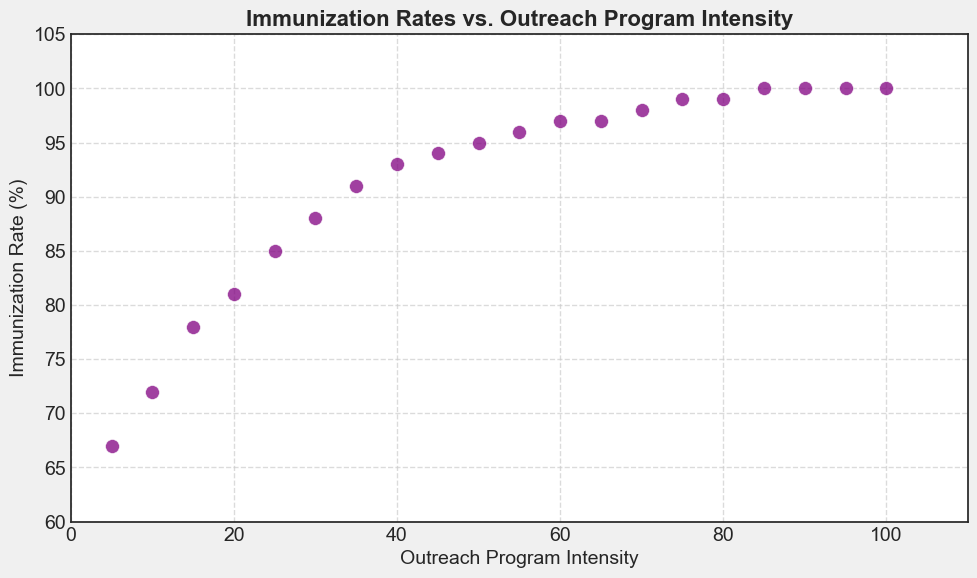What trend do you observe between Outreach Program Intensity and Immunization Rate? As Outreach Program Intensity increases, Immunization Rate also increases. The relationship appears to be positively correlated, indicating that more intense outreach programs are associated with higher immunization rates.
Answer: Positive correlation What is the Immunization Rate when the Outreach Program Intensity is 40? Locate the point where Outreach Program Intensity is 40 on the x-axis, and then look up to see where it intersects with the y-axis. The Immunization Rate at this point is 93%.
Answer: 93% At what value of Outreach Program Intensity does the Immunization Rate first reach 100%? Find the first data point where the y-axis value (Immunization Rate) reaches 100%. This occurs when Outreach Program Intensity is at 85.
Answer: 85 What is the difference in Immunization Rate between an Outreach Program Intensity of 25 and 50? Locate the Immunization Rates for Outreach Program Intensities of 25 and 50, which are 85% and 95% respectively. Subtract 85 from 95 to get the difference (95 - 85 = 10).
Answer: 10 Is there a point where increasing the Outreach Program Intensity does not increase the Immunization Rate? From Outreach Program Intensity of 85 onwards, the Immunization Rate is 100%, indicating that any further increase in intensity does not augment the Immunization Rate.
Answer: Yes At an Outreach Program Intensity of 30, how much higher is the Immunization Rate compared to an Intensity of 10? Locate the Immunization Rates for Outreach Program Intensities of 30 and 10, which are 88% and 72% respectively. Subtract 72 from 88 to find the difference (88 - 72 = 16).
Answer: 16 What is the average Immunization Rate for an Outreach Program Intensity ranging from 50 to 70? Find the Immunization Rates at 50, 55, 60, 65, and 70: 95%, 96%, 97%, 97%, and 98% respectively. Sum them up (95 + 96 + 97 + 97 + 98 = 483) and divide by 5 (483 / 5 = 96.6).
Answer: 96.6 Does the scatter plot show any outliers? Examine the scatter plot to see if any points fall far outside the general trend. All the points seem to follow the trend closely without deviating significantly.
Answer: No What happens to the Immunization Rate as the Outreach Program Intensity increases from 80 to 100? The Immunization Rate transitions from 99% to 100% as the Outreach Program Intensity increases from 80 to 100. This indicates a slight rise until the Immunization Rate plateaus at 100%.
Answer: It plateaus What visual attribute is used to represent data points in the scatter plot? The data points in the scatter plot are represented using purple circular markers with a white edge color.
Answer: Purple circles 